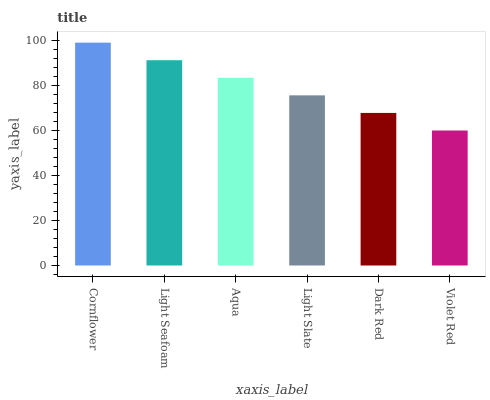Is Violet Red the minimum?
Answer yes or no. Yes. Is Cornflower the maximum?
Answer yes or no. Yes. Is Light Seafoam the minimum?
Answer yes or no. No. Is Light Seafoam the maximum?
Answer yes or no. No. Is Cornflower greater than Light Seafoam?
Answer yes or no. Yes. Is Light Seafoam less than Cornflower?
Answer yes or no. Yes. Is Light Seafoam greater than Cornflower?
Answer yes or no. No. Is Cornflower less than Light Seafoam?
Answer yes or no. No. Is Aqua the high median?
Answer yes or no. Yes. Is Light Slate the low median?
Answer yes or no. Yes. Is Dark Red the high median?
Answer yes or no. No. Is Dark Red the low median?
Answer yes or no. No. 